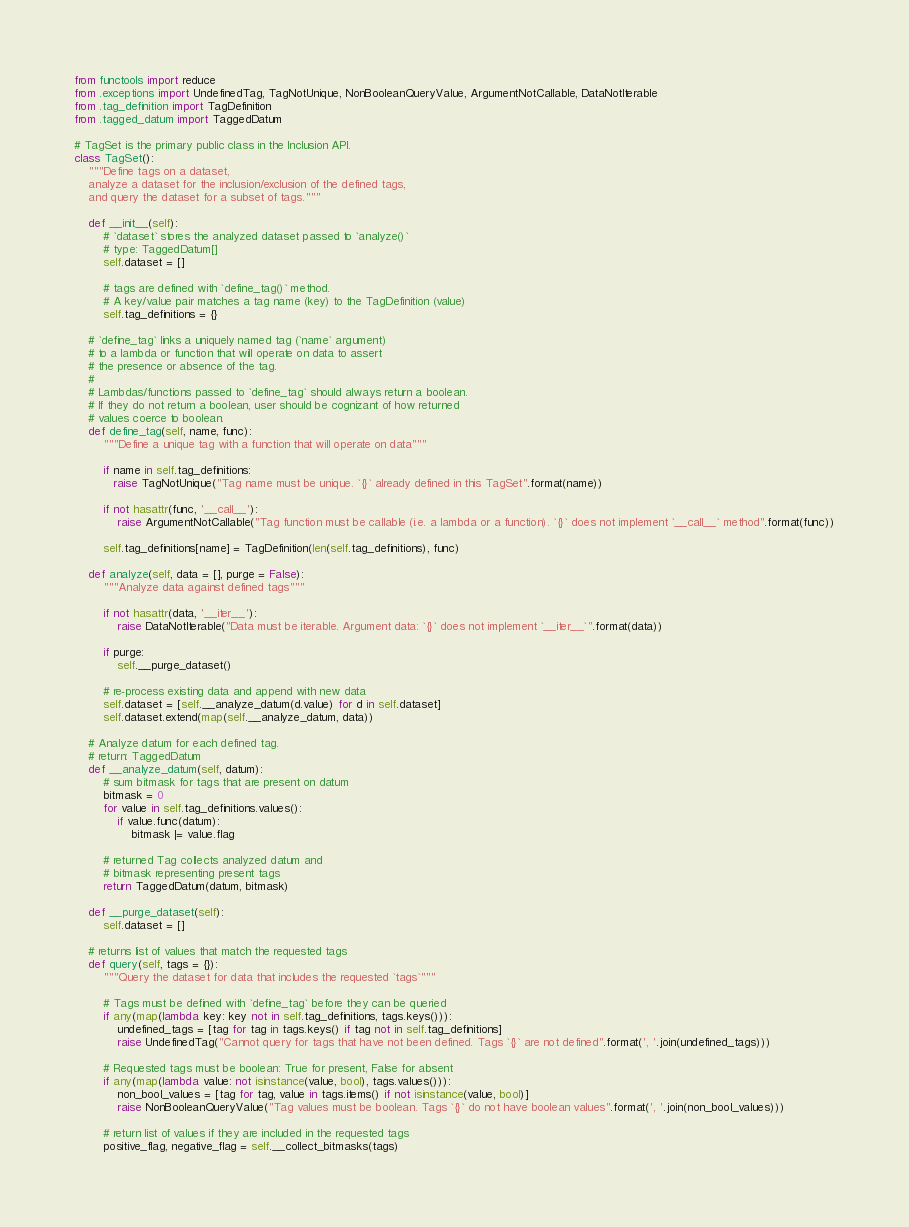<code> <loc_0><loc_0><loc_500><loc_500><_Python_>from functools import reduce
from .exceptions import UndefinedTag, TagNotUnique, NonBooleanQueryValue, ArgumentNotCallable, DataNotIterable
from .tag_definition import TagDefinition
from .tagged_datum import TaggedDatum

# TagSet is the primary public class in the Inclusion API.
class TagSet():
    """Define tags on a dataset,
    analyze a dataset for the inclusion/exclusion of the defined tags,
    and query the dataset for a subset of tags."""

    def __init__(self):
        # `dataset` stores the analyzed dataset passed to `analyze()`
        # type: TaggedDatum[]
        self.dataset = []

        # tags are defined with `define_tag()` method.
        # A key/value pair matches a tag name (key) to the TagDefinition (value)
        self.tag_definitions = {}

    # `define_tag` links a uniquely named tag (`name` argument)
    # to a lambda or function that will operate on data to assert
    # the presence or absence of the tag.
    #
    # Lambdas/functions passed to `define_tag` should always return a boolean.
    # If they do not return a boolean, user should be cognizant of how returned
    # values coerce to boolean.
    def define_tag(self, name, func):
        """Define a unique tag with a function that will operate on data"""

        if name in self.tag_definitions:
           raise TagNotUnique("Tag name must be unique. `{}` already defined in this TagSet".format(name))

        if not hasattr(func, '__call__'):
            raise ArgumentNotCallable("Tag function must be callable (i.e. a lambda or a function). `{}` does not implement `__call__` method".format(func))

        self.tag_definitions[name] = TagDefinition(len(self.tag_definitions), func)

    def analyze(self, data = [], purge = False):
        """Analyze data against defined tags"""

        if not hasattr(data, '__iter__'):
            raise DataNotIterable("Data must be iterable. Argument data: `{}` does not implement `__iter__`".format(data))

        if purge:
            self.__purge_dataset()

        # re-process existing data and append with new data
        self.dataset = [self.__analyze_datum(d.value) for d in self.dataset]
        self.dataset.extend(map(self.__analyze_datum, data))

    # Analyze datum for each defined tag.
    # return: TaggedDatum
    def __analyze_datum(self, datum):
        # sum bitmask for tags that are present on datum
        bitmask = 0
        for value in self.tag_definitions.values():
            if value.func(datum):
                bitmask |= value.flag

        # returned Tag collects analyzed datum and
        # bitmask representing present tags
        return TaggedDatum(datum, bitmask)

    def __purge_dataset(self):
        self.dataset = []

    # returns list of values that match the requested tags
    def query(self, tags = {}):
        """Query the dataset for data that includes the requested `tags`"""

        # Tags must be defined with `define_tag` before they can be queried
        if any(map(lambda key: key not in self.tag_definitions, tags.keys())):
            undefined_tags = [tag for tag in tags.keys() if tag not in self.tag_definitions]
            raise UndefinedTag("Cannot query for tags that have not been defined. Tags `{}` are not defined".format(', '.join(undefined_tags)))

        # Requested tags must be boolean: True for present, False for absent
        if any(map(lambda value: not isinstance(value, bool), tags.values())):
            non_bool_values = [tag for tag, value in tags.items() if not isinstance(value, bool)]
            raise NonBooleanQueryValue("Tag values must be boolean. Tags `{}` do not have boolean values".format(', '.join(non_bool_values)))

        # return list of values if they are included in the requested tags
        positive_flag, negative_flag = self.__collect_bitmasks(tags)</code> 